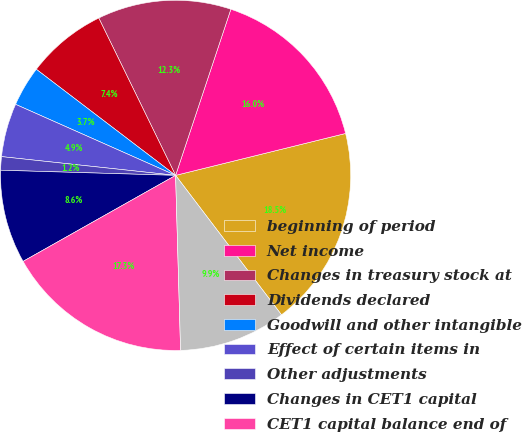<chart> <loc_0><loc_0><loc_500><loc_500><pie_chart><fcel>beginning of period<fcel>Net income<fcel>Changes in treasury stock at<fcel>Dividends declared<fcel>Goodwill and other intangible<fcel>Effect of certain items in<fcel>Other adjustments<fcel>Changes in CET1 capital<fcel>CET1 capital balance end of<fcel>Change in CET1 capital<nl><fcel>18.51%<fcel>16.04%<fcel>12.34%<fcel>7.41%<fcel>3.71%<fcel>4.94%<fcel>1.24%<fcel>8.64%<fcel>17.28%<fcel>9.88%<nl></chart> 